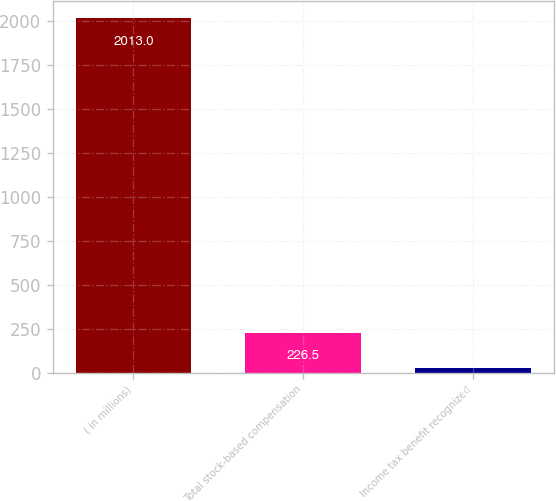<chart> <loc_0><loc_0><loc_500><loc_500><bar_chart><fcel>( in millions)<fcel>Total stock-based compensation<fcel>Income tax benefit recognized<nl><fcel>2013<fcel>226.5<fcel>28<nl></chart> 